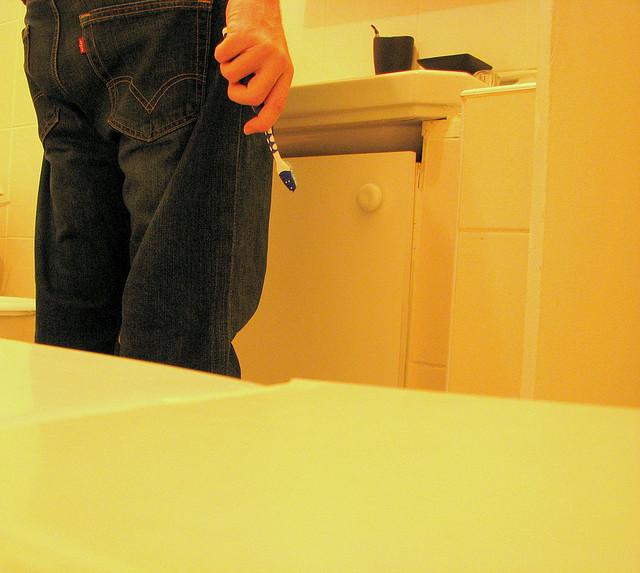What is the man holding?
Be succinct. Toothbrush. What brand of jeans is the man wearing?
Concise answer only. Levis. What room is he standing in?
Short answer required. Bathroom. 